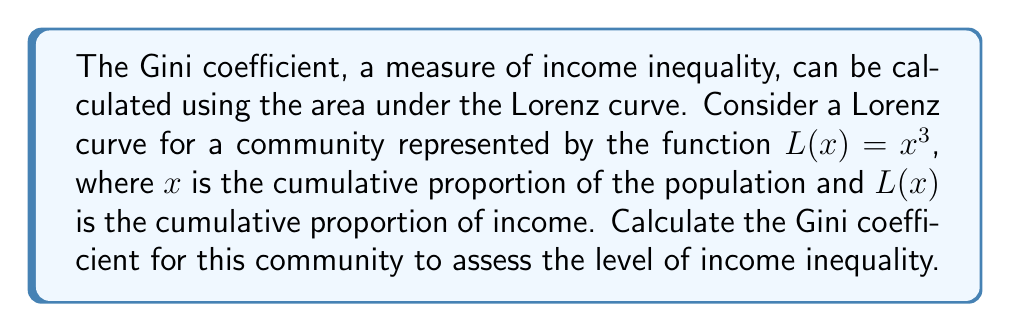Teach me how to tackle this problem. To solve this problem, we'll follow these steps:

1) The Gini coefficient is defined as twice the area between the Lorenz curve and the line of perfect equality (y = x).

2) The area between the line of equality and the Lorenz curve is:

   $$A = \int_0^1 (x - L(x)) dx$$

3) Substitute $L(x) = x^3$:

   $$A = \int_0^1 (x - x^3) dx$$

4) Integrate:

   $$A = [\frac{1}{2}x^2 - \frac{1}{4}x^4]_0^1$$

5) Evaluate the integral:

   $$A = (\frac{1}{2} - \frac{1}{4}) - (0 - 0) = \frac{1}{4}$$

6) The Gini coefficient is twice this area:

   $$\text{Gini} = 2A = 2 \cdot \frac{1}{4} = \frac{1}{2} = 0.5$$

This Gini coefficient of 0.5 indicates a significant level of income inequality in the community, as it's halfway between perfect equality (0) and perfect inequality (1).
Answer: $0.5$ 